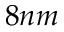<formula> <loc_0><loc_0><loc_500><loc_500>8 n m</formula> 